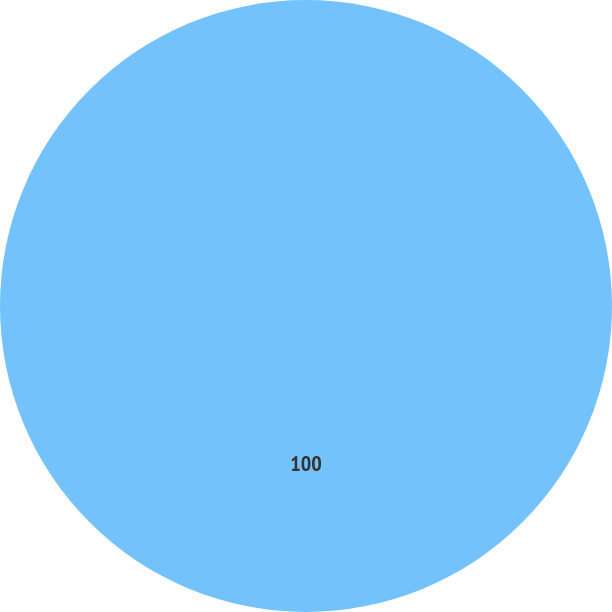<chart> <loc_0><loc_0><loc_500><loc_500><pie_chart><ecel><nl><fcel>100.0%<nl></chart> 